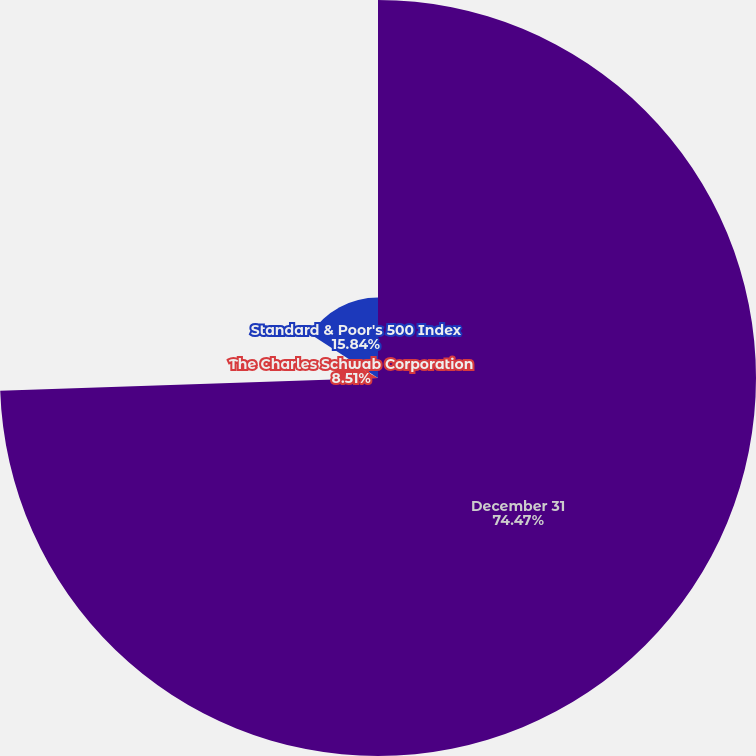Convert chart. <chart><loc_0><loc_0><loc_500><loc_500><pie_chart><fcel>December 31<fcel>The Charles Schwab Corporation<fcel>Dow Jones US Investment<fcel>Standard & Poor's 500 Index<nl><fcel>74.46%<fcel>8.51%<fcel>1.18%<fcel>15.84%<nl></chart> 